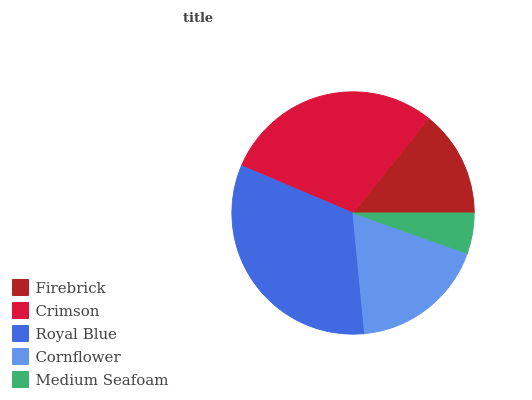Is Medium Seafoam the minimum?
Answer yes or no. Yes. Is Royal Blue the maximum?
Answer yes or no. Yes. Is Crimson the minimum?
Answer yes or no. No. Is Crimson the maximum?
Answer yes or no. No. Is Crimson greater than Firebrick?
Answer yes or no. Yes. Is Firebrick less than Crimson?
Answer yes or no. Yes. Is Firebrick greater than Crimson?
Answer yes or no. No. Is Crimson less than Firebrick?
Answer yes or no. No. Is Cornflower the high median?
Answer yes or no. Yes. Is Cornflower the low median?
Answer yes or no. Yes. Is Crimson the high median?
Answer yes or no. No. Is Royal Blue the low median?
Answer yes or no. No. 